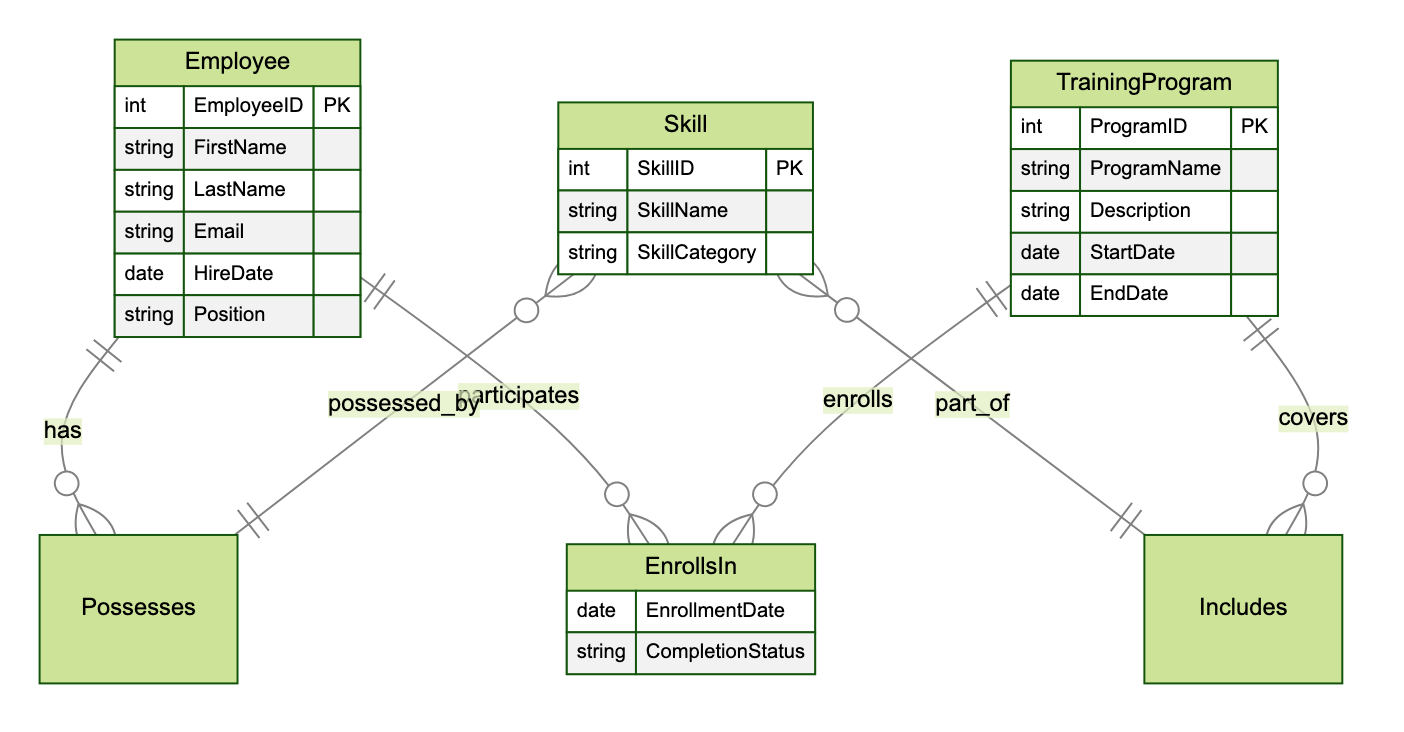What are the entities in the diagram? The diagram includes three entities: Employee, Skill, and TrainingProgram. Each entity represents a key component of the system being described.
Answer: Employee, Skill, TrainingProgram How many skills can an employee possess? An employee can possess multiple skills as represented by the many-to-one relationship indicated by the "Possesses" edge connecting Employee and Skill.
Answer: Many What attributes does the TrainingProgram entity have? The TrainingProgram entity has five attributes: ProgramID, ProgramName, Description, StartDate, and EndDate, which are shown as part of the entity's definition.
Answer: ProgramID, ProgramName, Description, StartDate, EndDate What relationship connects Employee and Skill? The relationship connecting Employee and Skill is called "Possesses," which indicates that employees can possess various skills.
Answer: Possesses What additional information is associated with the EnrollsIn relationship? The EnrollsIn relationship includes two attributes: EnrollmentDate and CompletionStatus, which provide further details about the enrollment process.
Answer: EnrollmentDate, CompletionStatus How many distinct relationships are there in the diagram? There are three distinct relationships in the diagram: Possesses, EnrollsIn, and Includes, which connect the involved entities together.
Answer: Three Which entity has a many-to-one relationship with TrainingProgram? The Employee entity has a many-to-one relationship with the TrainingProgram through the EnrollsIn relationship, indicating that multiple employees can enroll in the same training program.
Answer: Employee What type of relationship exists between TrainingProgram and Skill? The relationship between TrainingProgram and Skill is called "Includes," which indicates that training programs can include various skills as part of their curriculum.
Answer: Includes What information does the Includes relationship provide? The Includes relationship does not provide additional attributes; it simply shows the connection between TrainingProgram and Skill without extra data.
Answer: None 